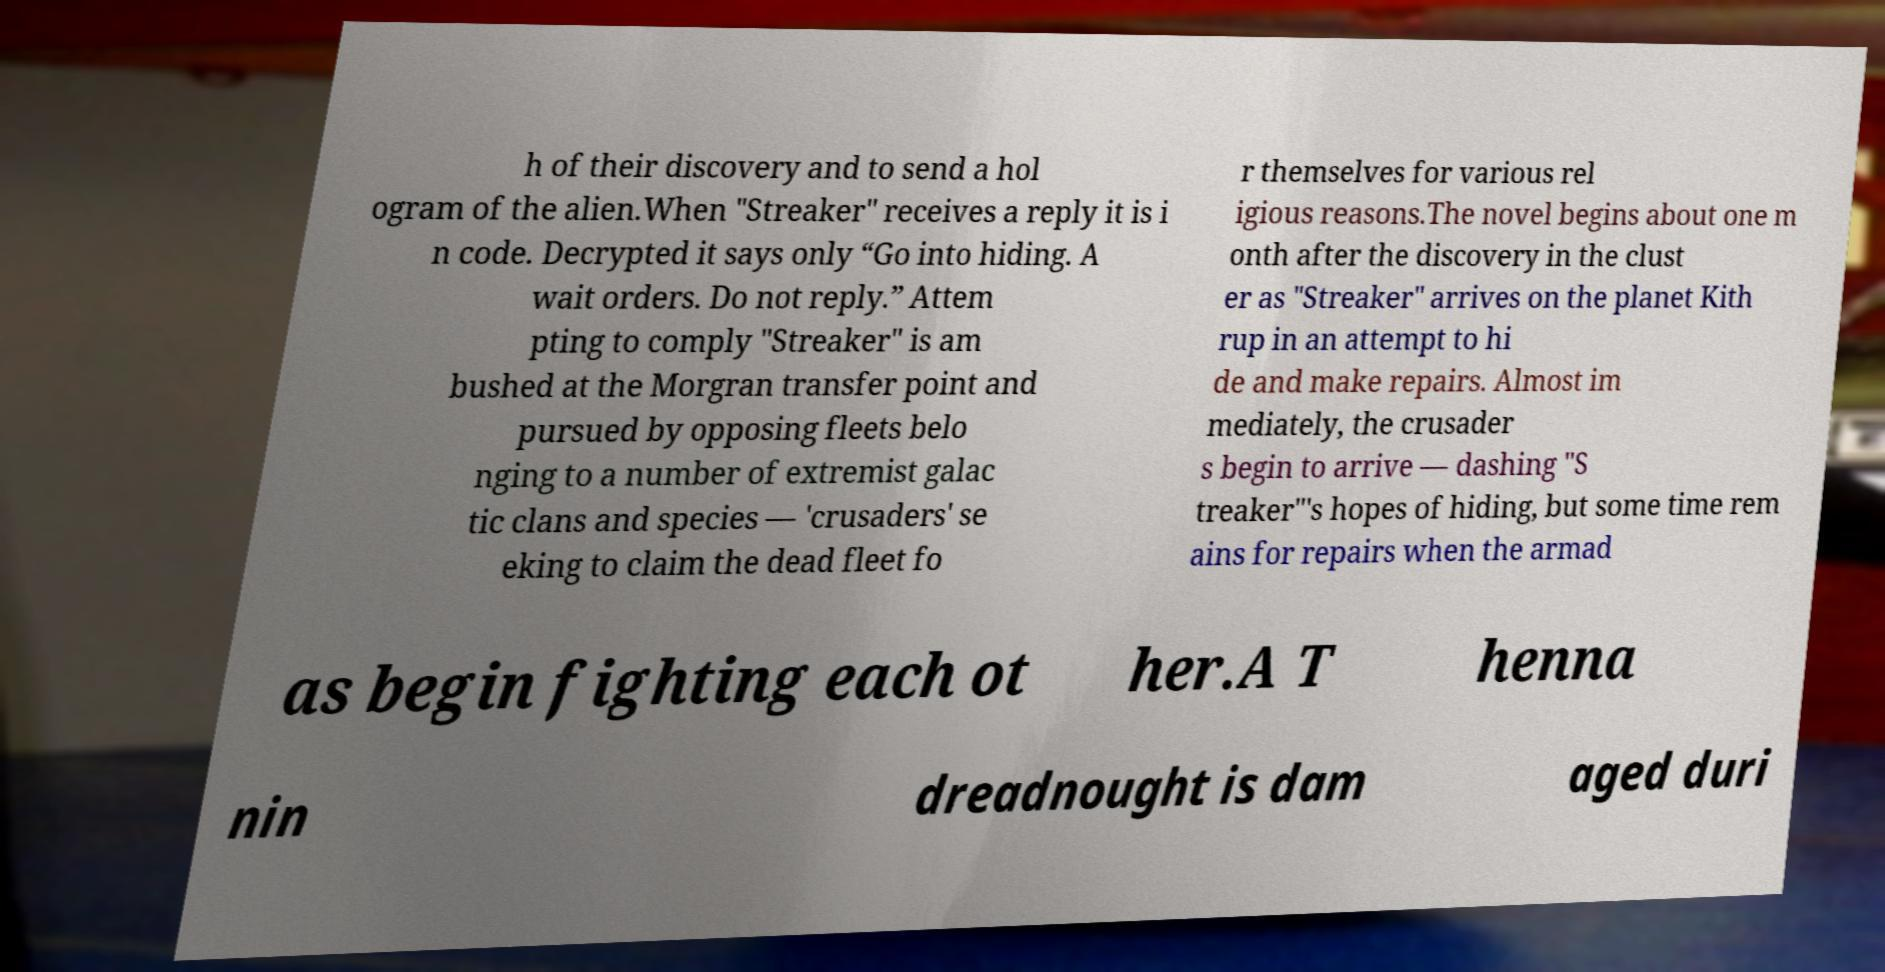For documentation purposes, I need the text within this image transcribed. Could you provide that? h of their discovery and to send a hol ogram of the alien.When "Streaker" receives a reply it is i n code. Decrypted it says only “Go into hiding. A wait orders. Do not reply.” Attem pting to comply "Streaker" is am bushed at the Morgran transfer point and pursued by opposing fleets belo nging to a number of extremist galac tic clans and species — 'crusaders' se eking to claim the dead fleet fo r themselves for various rel igious reasons.The novel begins about one m onth after the discovery in the clust er as "Streaker" arrives on the planet Kith rup in an attempt to hi de and make repairs. Almost im mediately, the crusader s begin to arrive — dashing "S treaker"'s hopes of hiding, but some time rem ains for repairs when the armad as begin fighting each ot her.A T henna nin dreadnought is dam aged duri 